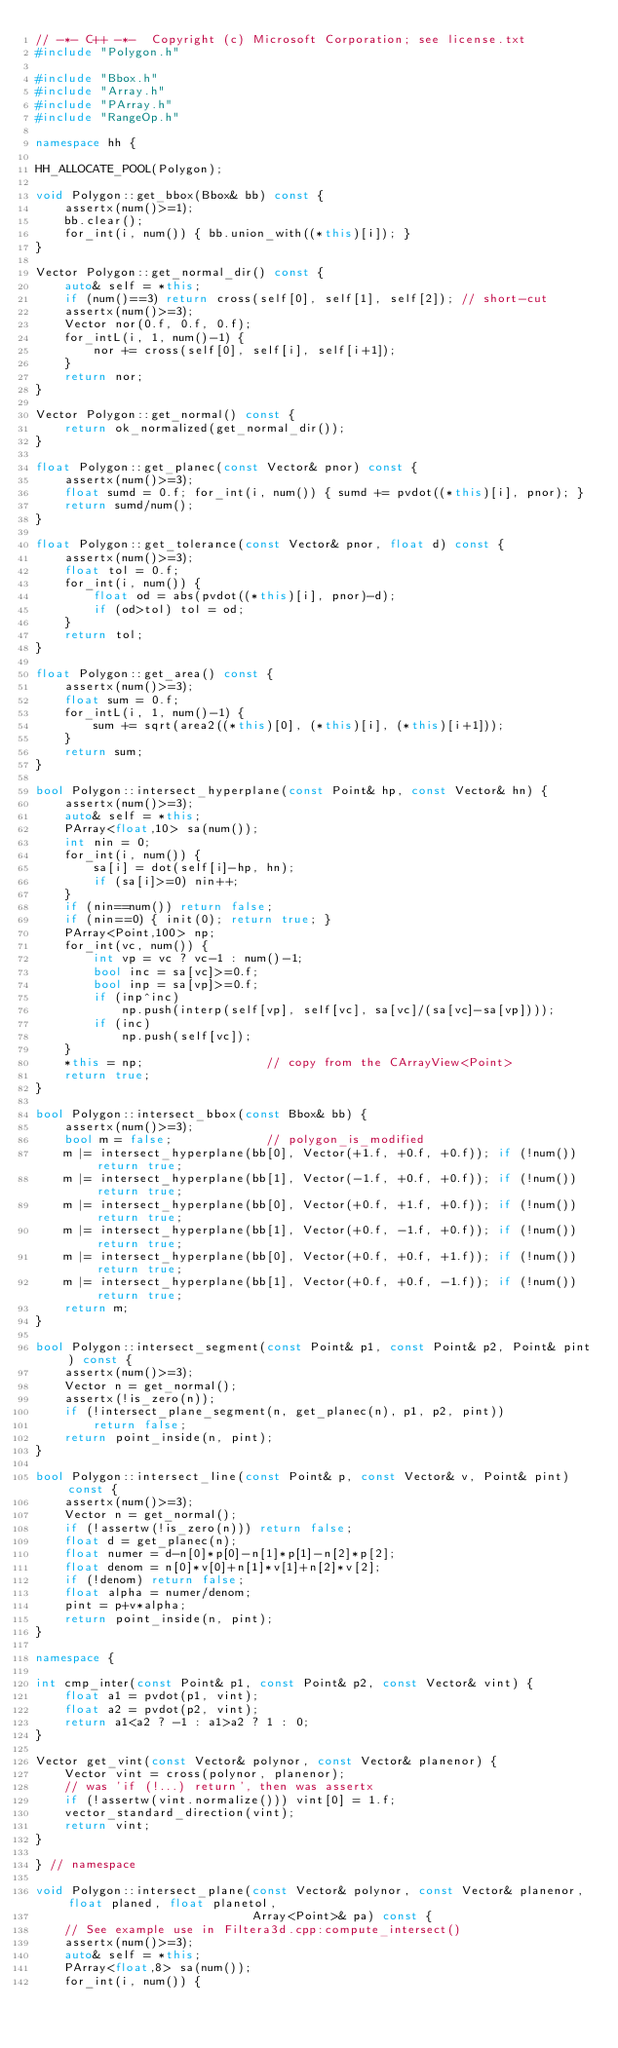Convert code to text. <code><loc_0><loc_0><loc_500><loc_500><_C++_>// -*- C++ -*-  Copyright (c) Microsoft Corporation; see license.txt
#include "Polygon.h"

#include "Bbox.h"
#include "Array.h"
#include "PArray.h"
#include "RangeOp.h"

namespace hh {

HH_ALLOCATE_POOL(Polygon);

void Polygon::get_bbox(Bbox& bb) const {
    assertx(num()>=1);
    bb.clear();
    for_int(i, num()) { bb.union_with((*this)[i]); }
}

Vector Polygon::get_normal_dir() const {
    auto& self = *this;
    if (num()==3) return cross(self[0], self[1], self[2]); // short-cut
    assertx(num()>=3);
    Vector nor(0.f, 0.f, 0.f);
    for_intL(i, 1, num()-1) {
        nor += cross(self[0], self[i], self[i+1]);
    }
    return nor;
}

Vector Polygon::get_normal() const {
    return ok_normalized(get_normal_dir());
}

float Polygon::get_planec(const Vector& pnor) const {
    assertx(num()>=3);
    float sumd = 0.f; for_int(i, num()) { sumd += pvdot((*this)[i], pnor); }
    return sumd/num();
}

float Polygon::get_tolerance(const Vector& pnor, float d) const {
    assertx(num()>=3);
    float tol = 0.f;
    for_int(i, num()) {
        float od = abs(pvdot((*this)[i], pnor)-d);
        if (od>tol) tol = od;
    }
    return tol;
}

float Polygon::get_area() const {
    assertx(num()>=3);
    float sum = 0.f;
    for_intL(i, 1, num()-1) {
        sum += sqrt(area2((*this)[0], (*this)[i], (*this)[i+1]));
    }
    return sum;
}

bool Polygon::intersect_hyperplane(const Point& hp, const Vector& hn) {
    assertx(num()>=3);
    auto& self = *this;
    PArray<float,10> sa(num());
    int nin = 0;
    for_int(i, num()) {
        sa[i] = dot(self[i]-hp, hn);
        if (sa[i]>=0) nin++;
    }
    if (nin==num()) return false;
    if (nin==0) { init(0); return true; }
    PArray<Point,100> np;
    for_int(vc, num()) {
        int vp = vc ? vc-1 : num()-1;
        bool inc = sa[vc]>=0.f;
        bool inp = sa[vp]>=0.f;
        if (inp^inc)
            np.push(interp(self[vp], self[vc], sa[vc]/(sa[vc]-sa[vp])));
        if (inc)
            np.push(self[vc]);
    }
    *this = np;                 // copy from the CArrayView<Point>
    return true;
}

bool Polygon::intersect_bbox(const Bbox& bb) {
    assertx(num()>=3);
    bool m = false;             // polygon_is_modified
    m |= intersect_hyperplane(bb[0], Vector(+1.f, +0.f, +0.f)); if (!num()) return true;
    m |= intersect_hyperplane(bb[1], Vector(-1.f, +0.f, +0.f)); if (!num()) return true;
    m |= intersect_hyperplane(bb[0], Vector(+0.f, +1.f, +0.f)); if (!num()) return true;
    m |= intersect_hyperplane(bb[1], Vector(+0.f, -1.f, +0.f)); if (!num()) return true;
    m |= intersect_hyperplane(bb[0], Vector(+0.f, +0.f, +1.f)); if (!num()) return true;
    m |= intersect_hyperplane(bb[1], Vector(+0.f, +0.f, -1.f)); if (!num()) return true;
    return m;
}

bool Polygon::intersect_segment(const Point& p1, const Point& p2, Point& pint) const {
    assertx(num()>=3);
    Vector n = get_normal();
    assertx(!is_zero(n));
    if (!intersect_plane_segment(n, get_planec(n), p1, p2, pint))
        return false;
    return point_inside(n, pint);
}

bool Polygon::intersect_line(const Point& p, const Vector& v, Point& pint) const {
    assertx(num()>=3);
    Vector n = get_normal();
    if (!assertw(!is_zero(n))) return false;
    float d = get_planec(n);
    float numer = d-n[0]*p[0]-n[1]*p[1]-n[2]*p[2];
    float denom = n[0]*v[0]+n[1]*v[1]+n[2]*v[2];
    if (!denom) return false;
    float alpha = numer/denom;
    pint = p+v*alpha;
    return point_inside(n, pint);
}

namespace {

int cmp_inter(const Point& p1, const Point& p2, const Vector& vint) {
    float a1 = pvdot(p1, vint);
    float a2 = pvdot(p2, vint);
    return a1<a2 ? -1 : a1>a2 ? 1 : 0;
}

Vector get_vint(const Vector& polynor, const Vector& planenor) {
    Vector vint = cross(polynor, planenor);
    // was 'if (!...) return', then was assertx
    if (!assertw(vint.normalize())) vint[0] = 1.f;
    vector_standard_direction(vint);
    return vint;
}

} // namespace

void Polygon::intersect_plane(const Vector& polynor, const Vector& planenor, float planed, float planetol,
                              Array<Point>& pa) const {
    // See example use in Filtera3d.cpp:compute_intersect()
    assertx(num()>=3);
    auto& self = *this;
    PArray<float,8> sa(num());
    for_int(i, num()) {</code> 